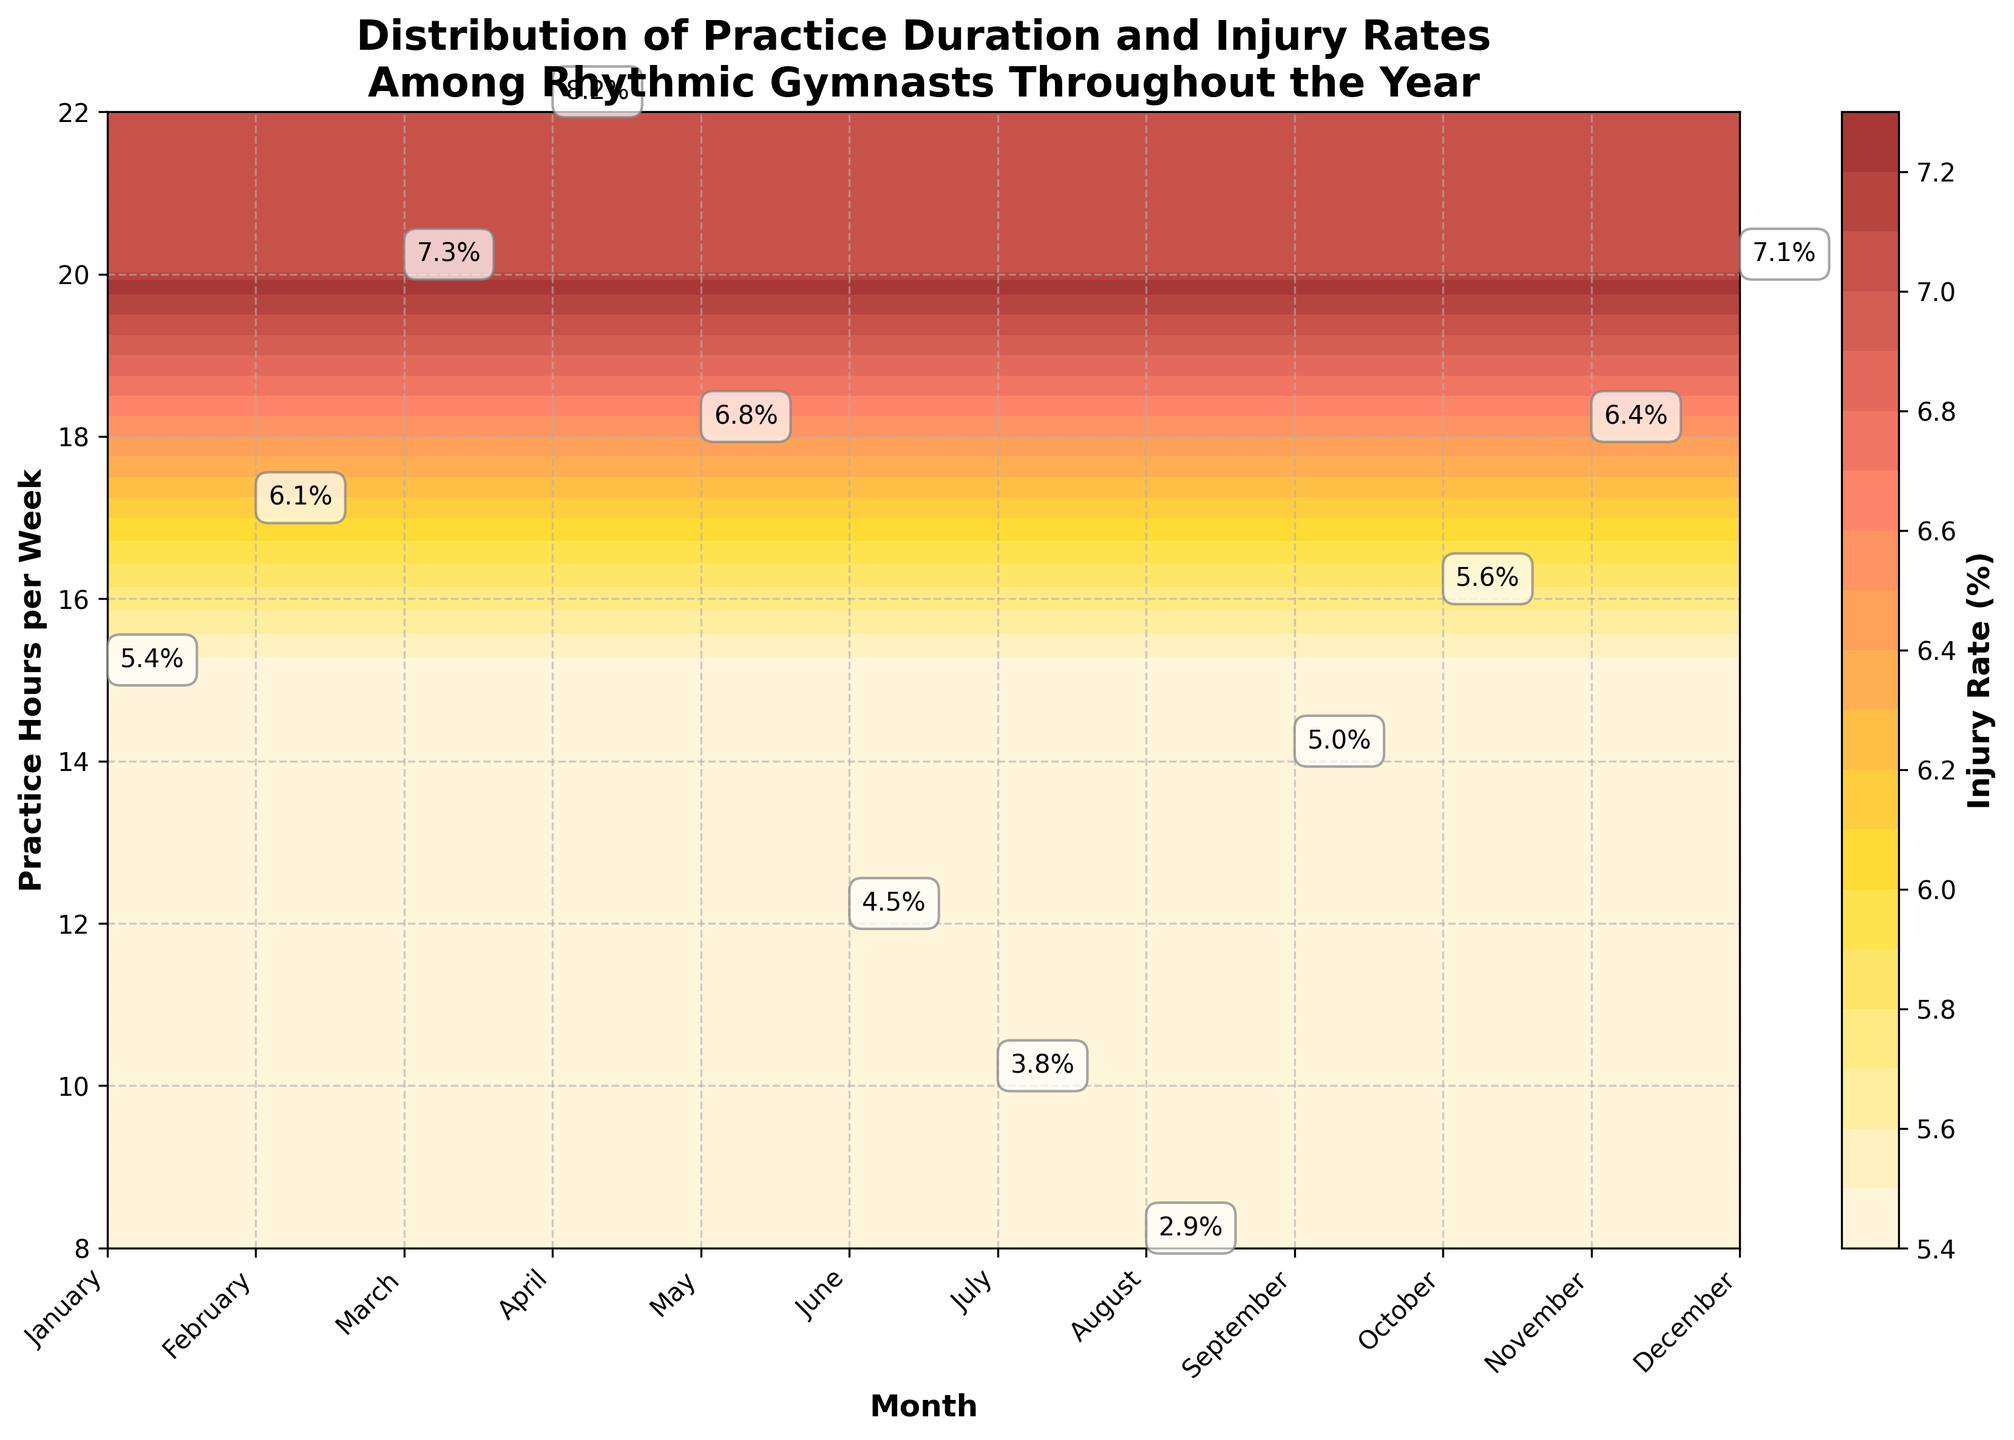What is the title of the plot? The title of the plot is usually located at the top of the figure. In this case, it reads "Distribution of Practice Duration and Injury Rates Among Rhythmic Gymnasts Throughout the Year".
Answer: Distribution of Practice Duration and Injury Rates Among Rhythmic Gymnasts Throughout the Year What are the labels of the x-axis and y-axis? The x-axis label is observed at the bottom horizontal axis, and it reads "Month". The y-axis label is found at the vertical axis on the left side, and it reads "Practice Hours per Week".
Answer: Month and Practice Hours per Week Which month has the highest practice hours per week and what is its injury rate? To find the month with the highest practice hours per week, we look for the highest point on the y-axis where it lines up with a month. December has the highest practice hours per week at 22, and the injury rate label close to this coordinate is seen as 8.2%.
Answer: December, 8.2% During which month is the injury rate the lowest and what are the practice hours per week during that month? To determine the month with the lowest injury rate, we examine the injury rates labeled next to the month's points on the plot. August has the lowest injury rate at 2.9%. The corresponding practice hours per week for August is 8.
Answer: August, 8 How does the injury rate in March compare to that in November? Look for the labeled injury rates for the months March and November. March has an injury rate of 7.3%, while November has an injury rate of 6.4%. We can see that the injury rate in March is higher than in November.
Answer: March has a higher injury rate than November What is the average practice hours per week for the months with injury rates above 7.0%? First, identify the months with injury rates above 7.0%: March (7.3%), April (8.2%), and December (7.1%). Their corresponding practice hours per week are 20, 22, and 20 respectively. Calculate the average by summing these hours and dividing by the number of months: (20 + 22 + 20) / 3 = 62 / 3 = 20.67 hours per week.
Answer: 20.67 hours per week Which month has the closest injury rate to that of October, and what is the corresponding practice hours per week for that month? Identify the injury rate label for October, which is 5.6%. Then look for the month with the closest injury rate: January (5.4%) is the closest. The practice hours per week for January is 15.
Answer: January, 15 During which months are the practice hours per week between 12 and 16 inclusive, and what are the corresponding injury rates? Look at the y-axis range from 12 to 16 and identify the months falling within these hours: September (14), October (16), and February (17 slightly above the range). Their corresponding injury rates are 5.0%, 5.6%, and 6.1% respectively.
Answer: September: 5.0%, October: 5.6% What trend do you observe between practice hours per week and injury rates throughout the year? Observing the overall distribution, there is a trend that as practice hours per week increase, injury rates also tend to increase. This can be deduced from the higher injury rates corresponding to higher practice hours across different months.
Answer: Increasing practice hours are associated with higher injury rates 